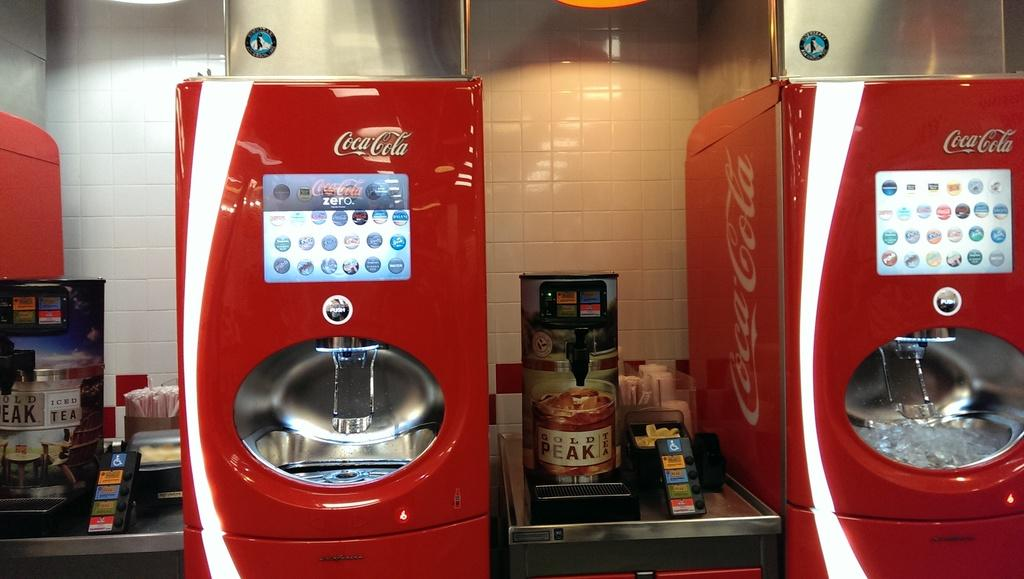<image>
Share a concise interpretation of the image provided. two red machine with the coca cola logos on the top 